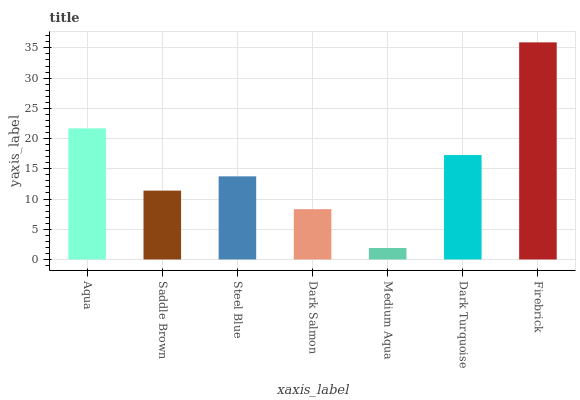Is Medium Aqua the minimum?
Answer yes or no. Yes. Is Firebrick the maximum?
Answer yes or no. Yes. Is Saddle Brown the minimum?
Answer yes or no. No. Is Saddle Brown the maximum?
Answer yes or no. No. Is Aqua greater than Saddle Brown?
Answer yes or no. Yes. Is Saddle Brown less than Aqua?
Answer yes or no. Yes. Is Saddle Brown greater than Aqua?
Answer yes or no. No. Is Aqua less than Saddle Brown?
Answer yes or no. No. Is Steel Blue the high median?
Answer yes or no. Yes. Is Steel Blue the low median?
Answer yes or no. Yes. Is Aqua the high median?
Answer yes or no. No. Is Dark Salmon the low median?
Answer yes or no. No. 